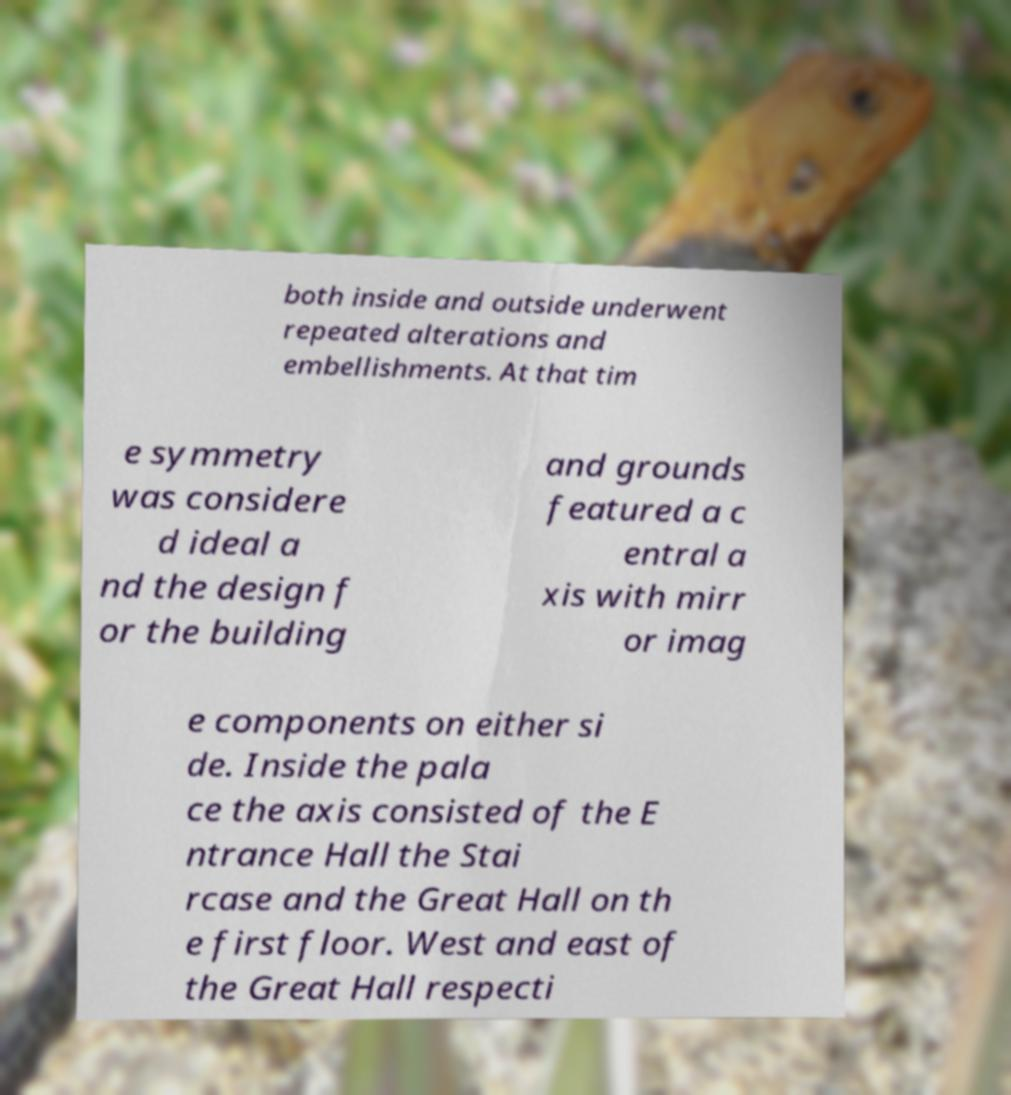For documentation purposes, I need the text within this image transcribed. Could you provide that? both inside and outside underwent repeated alterations and embellishments. At that tim e symmetry was considere d ideal a nd the design f or the building and grounds featured a c entral a xis with mirr or imag e components on either si de. Inside the pala ce the axis consisted of the E ntrance Hall the Stai rcase and the Great Hall on th e first floor. West and east of the Great Hall respecti 